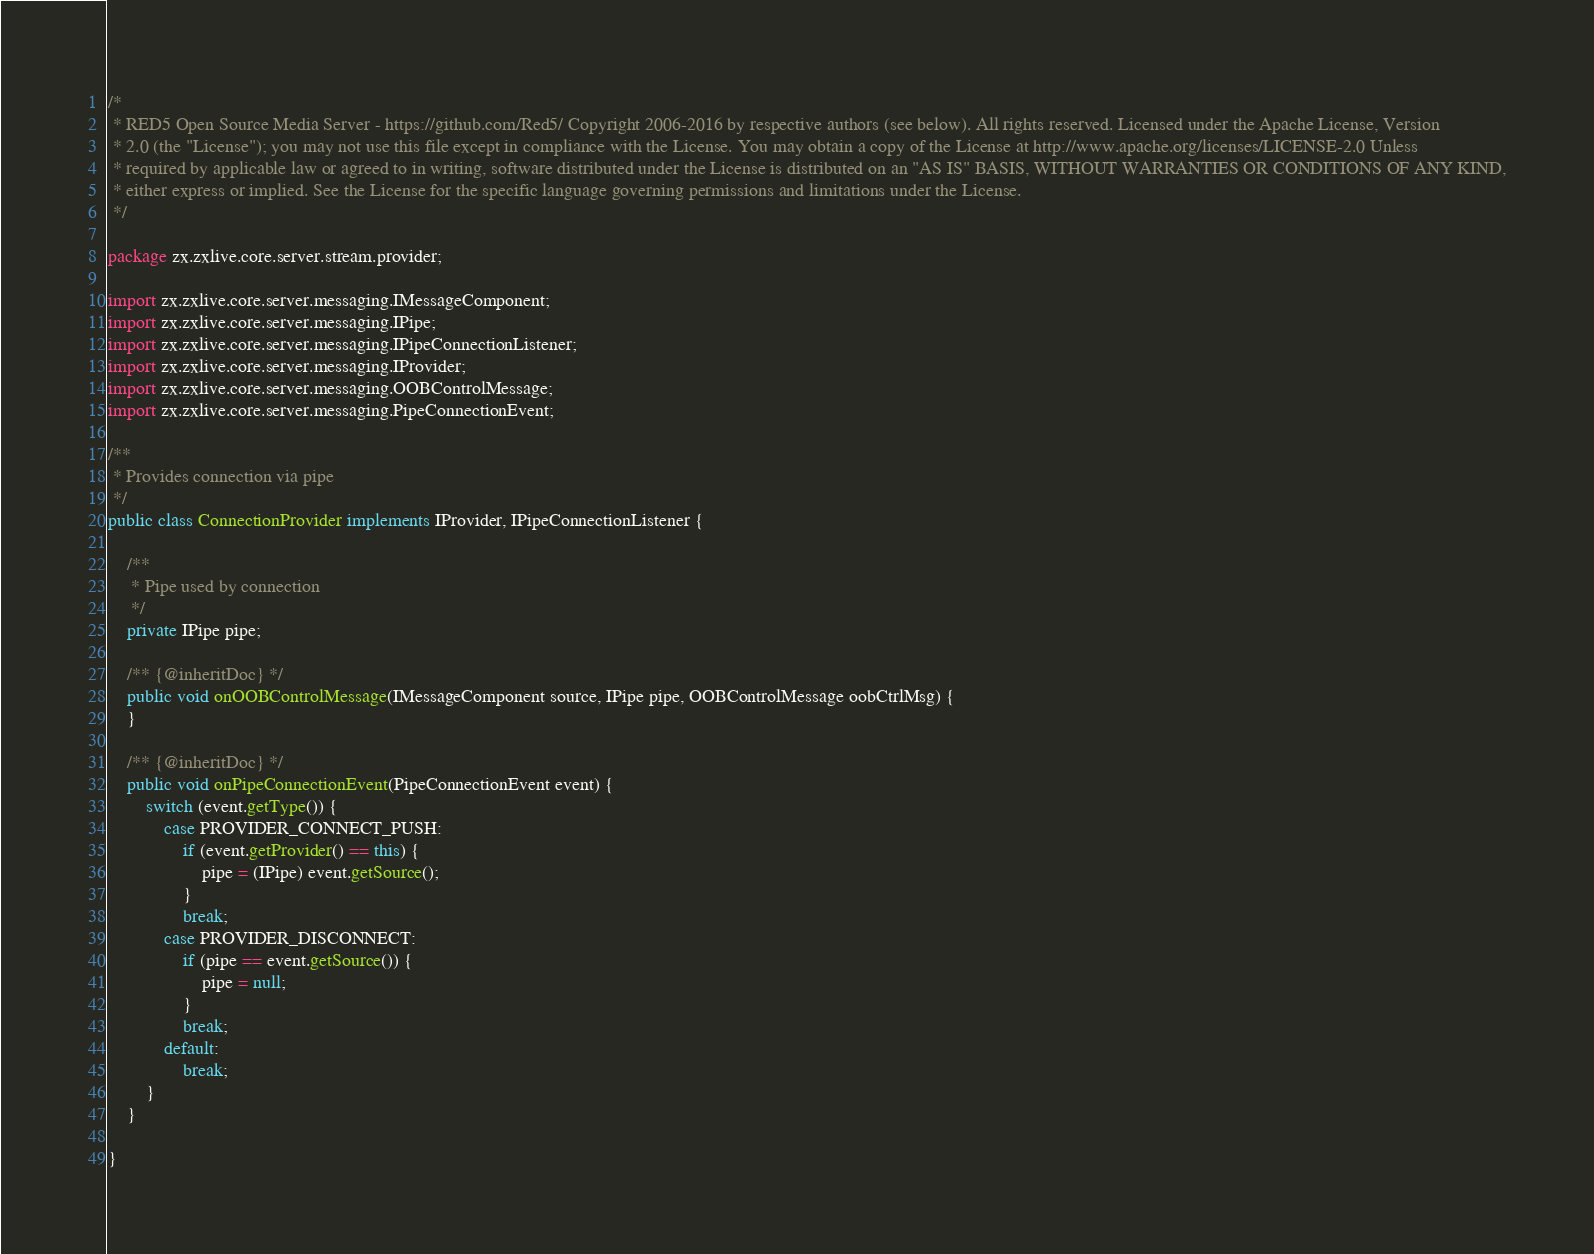<code> <loc_0><loc_0><loc_500><loc_500><_Java_>/*
 * RED5 Open Source Media Server - https://github.com/Red5/ Copyright 2006-2016 by respective authors (see below). All rights reserved. Licensed under the Apache License, Version
 * 2.0 (the "License"); you may not use this file except in compliance with the License. You may obtain a copy of the License at http://www.apache.org/licenses/LICENSE-2.0 Unless
 * required by applicable law or agreed to in writing, software distributed under the License is distributed on an "AS IS" BASIS, WITHOUT WARRANTIES OR CONDITIONS OF ANY KIND,
 * either express or implied. See the License for the specific language governing permissions and limitations under the License.
 */

package zx.zxlive.core.server.stream.provider;

import zx.zxlive.core.server.messaging.IMessageComponent;
import zx.zxlive.core.server.messaging.IPipe;
import zx.zxlive.core.server.messaging.IPipeConnectionListener;
import zx.zxlive.core.server.messaging.IProvider;
import zx.zxlive.core.server.messaging.OOBControlMessage;
import zx.zxlive.core.server.messaging.PipeConnectionEvent;

/**
 * Provides connection via pipe
 */
public class ConnectionProvider implements IProvider, IPipeConnectionListener {

    /**
     * Pipe used by connection
     */
    private IPipe pipe;

    /** {@inheritDoc} */
    public void onOOBControlMessage(IMessageComponent source, IPipe pipe, OOBControlMessage oobCtrlMsg) {
    }

    /** {@inheritDoc} */
    public void onPipeConnectionEvent(PipeConnectionEvent event) {
        switch (event.getType()) {
            case PROVIDER_CONNECT_PUSH:
                if (event.getProvider() == this) {
                    pipe = (IPipe) event.getSource();
                }
                break;
            case PROVIDER_DISCONNECT:
                if (pipe == event.getSource()) {
                    pipe = null;
                }
                break;
            default:
                break;
        }
    }

}
</code> 